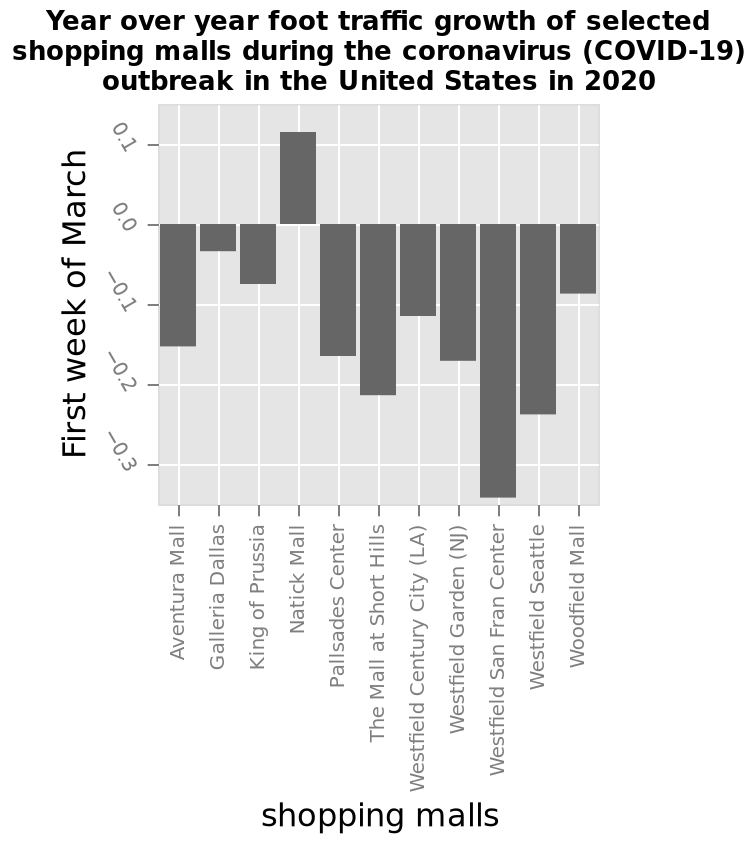<image>
Is there any mall that does not experience consistent foot traffic growth?  Yes, there is one mall that does not experience consistent foot traffic growth. What is the selection criteria for shopping malls in the chart? The selected shopping malls represent the foot traffic growth during the COVID-19 outbreak in the United States in 2020. What is the range of the y-axis? The y-axis ranges from -0.3 to 0.1. What is the title of the bar chart?  The title of the bar chart is "Year over year foot traffic growth of selected shopping malls during the coronavirus (COVID-19) outbreak in the United States in 2020." 